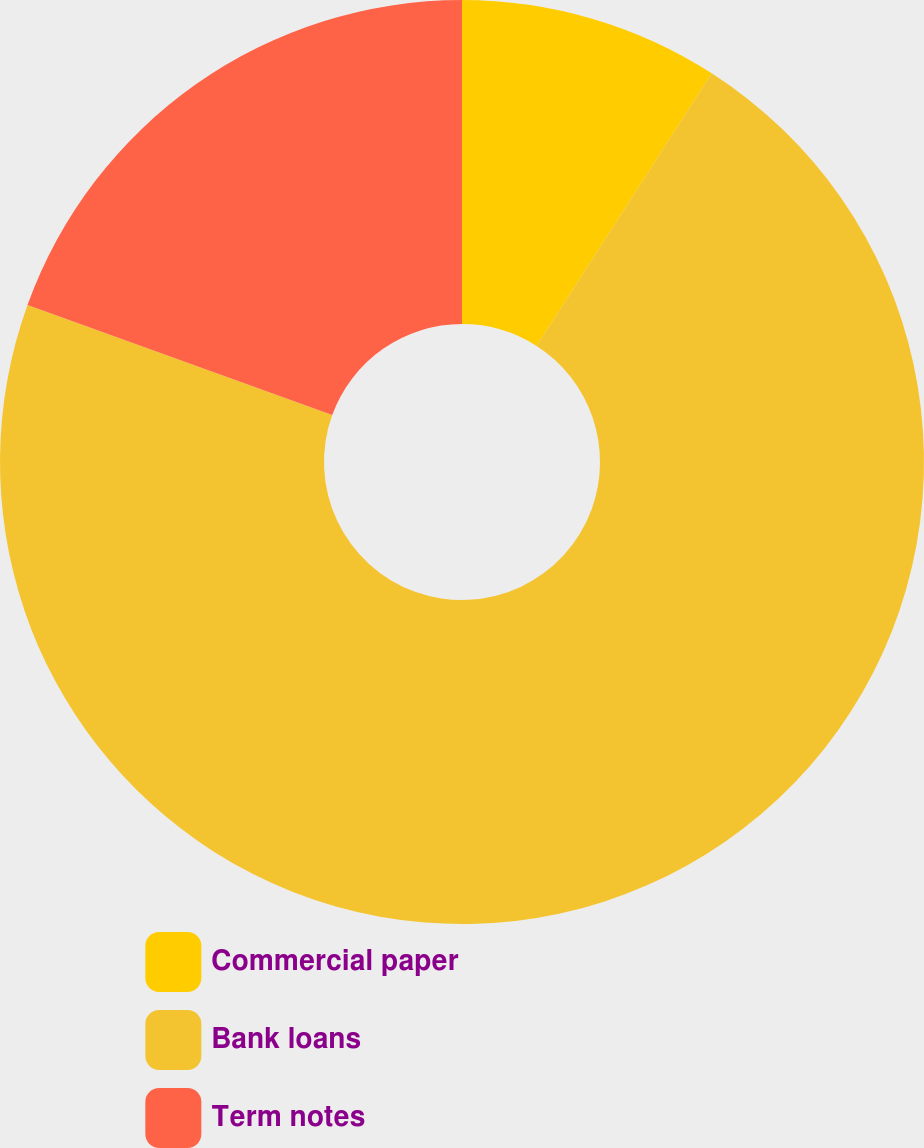Convert chart. <chart><loc_0><loc_0><loc_500><loc_500><pie_chart><fcel>Commercial paper<fcel>Bank loans<fcel>Term notes<nl><fcel>9.09%<fcel>71.43%<fcel>19.48%<nl></chart> 